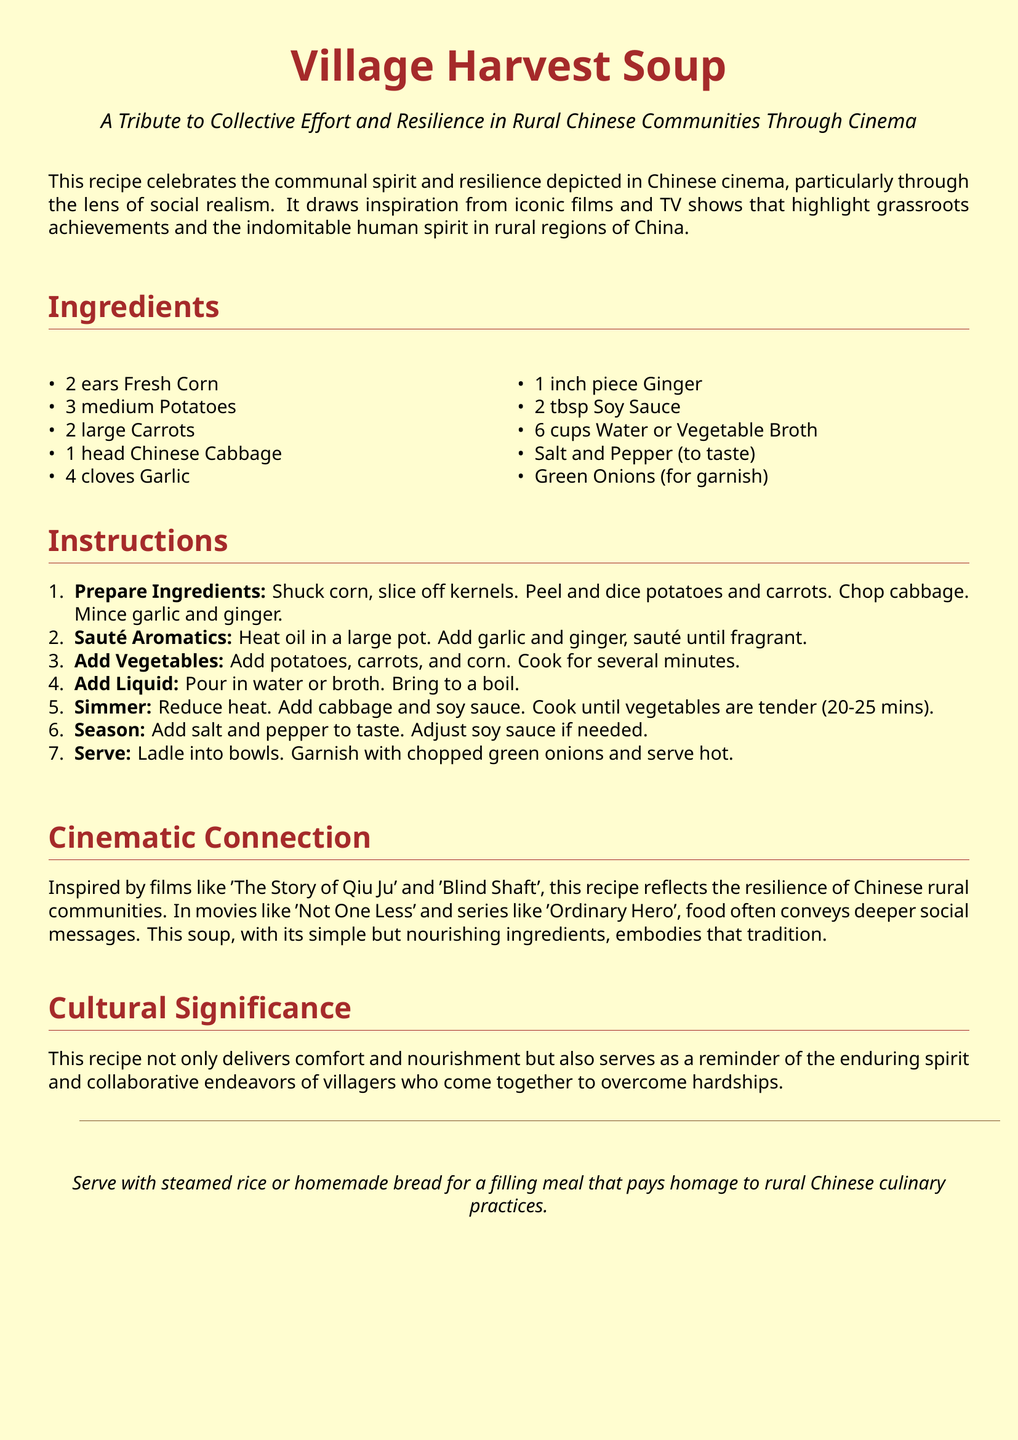What are the main ingredients? The document lists the ingredients needed for the soup in a specific section.
Answer: Fresh Corn, Potatoes, Carrots, Chinese Cabbage, Garlic, Ginger, Soy Sauce, Water or Vegetable Broth, Salt and Pepper, Green Onions What is the cooking time for the soup? The instructions indicate the cooking duration needed until the vegetables are tender.
Answer: 20-25 mins Which film is mentioned as an inspiration? The document highlights films that reflect the themes of the recipe, citing specific titles.
Answer: The Story of Qiu Ju What is the suggested garnish for the soup? In the instructions, it notes how to finish the dish before serving.
Answer: Chopped green onions How many ears of corn are needed? The ingredient list specifies the quantity of corn required for the recipe.
Answer: 2 ears What is the cultural significance of the recipe? The document explains the broader meaning behind the recipe, connecting it to social themes in rural communities.
Answer: Enduring spirit and collaborative endeavors What is the main theme of the recipe? In the introductory paragraph, it describes what the recipe represents.
Answer: Collective effort and resilience What is suggested to serve with the soup? The last section mentions additional food items that complement the dish.
Answer: Steamed rice or homemade bread 